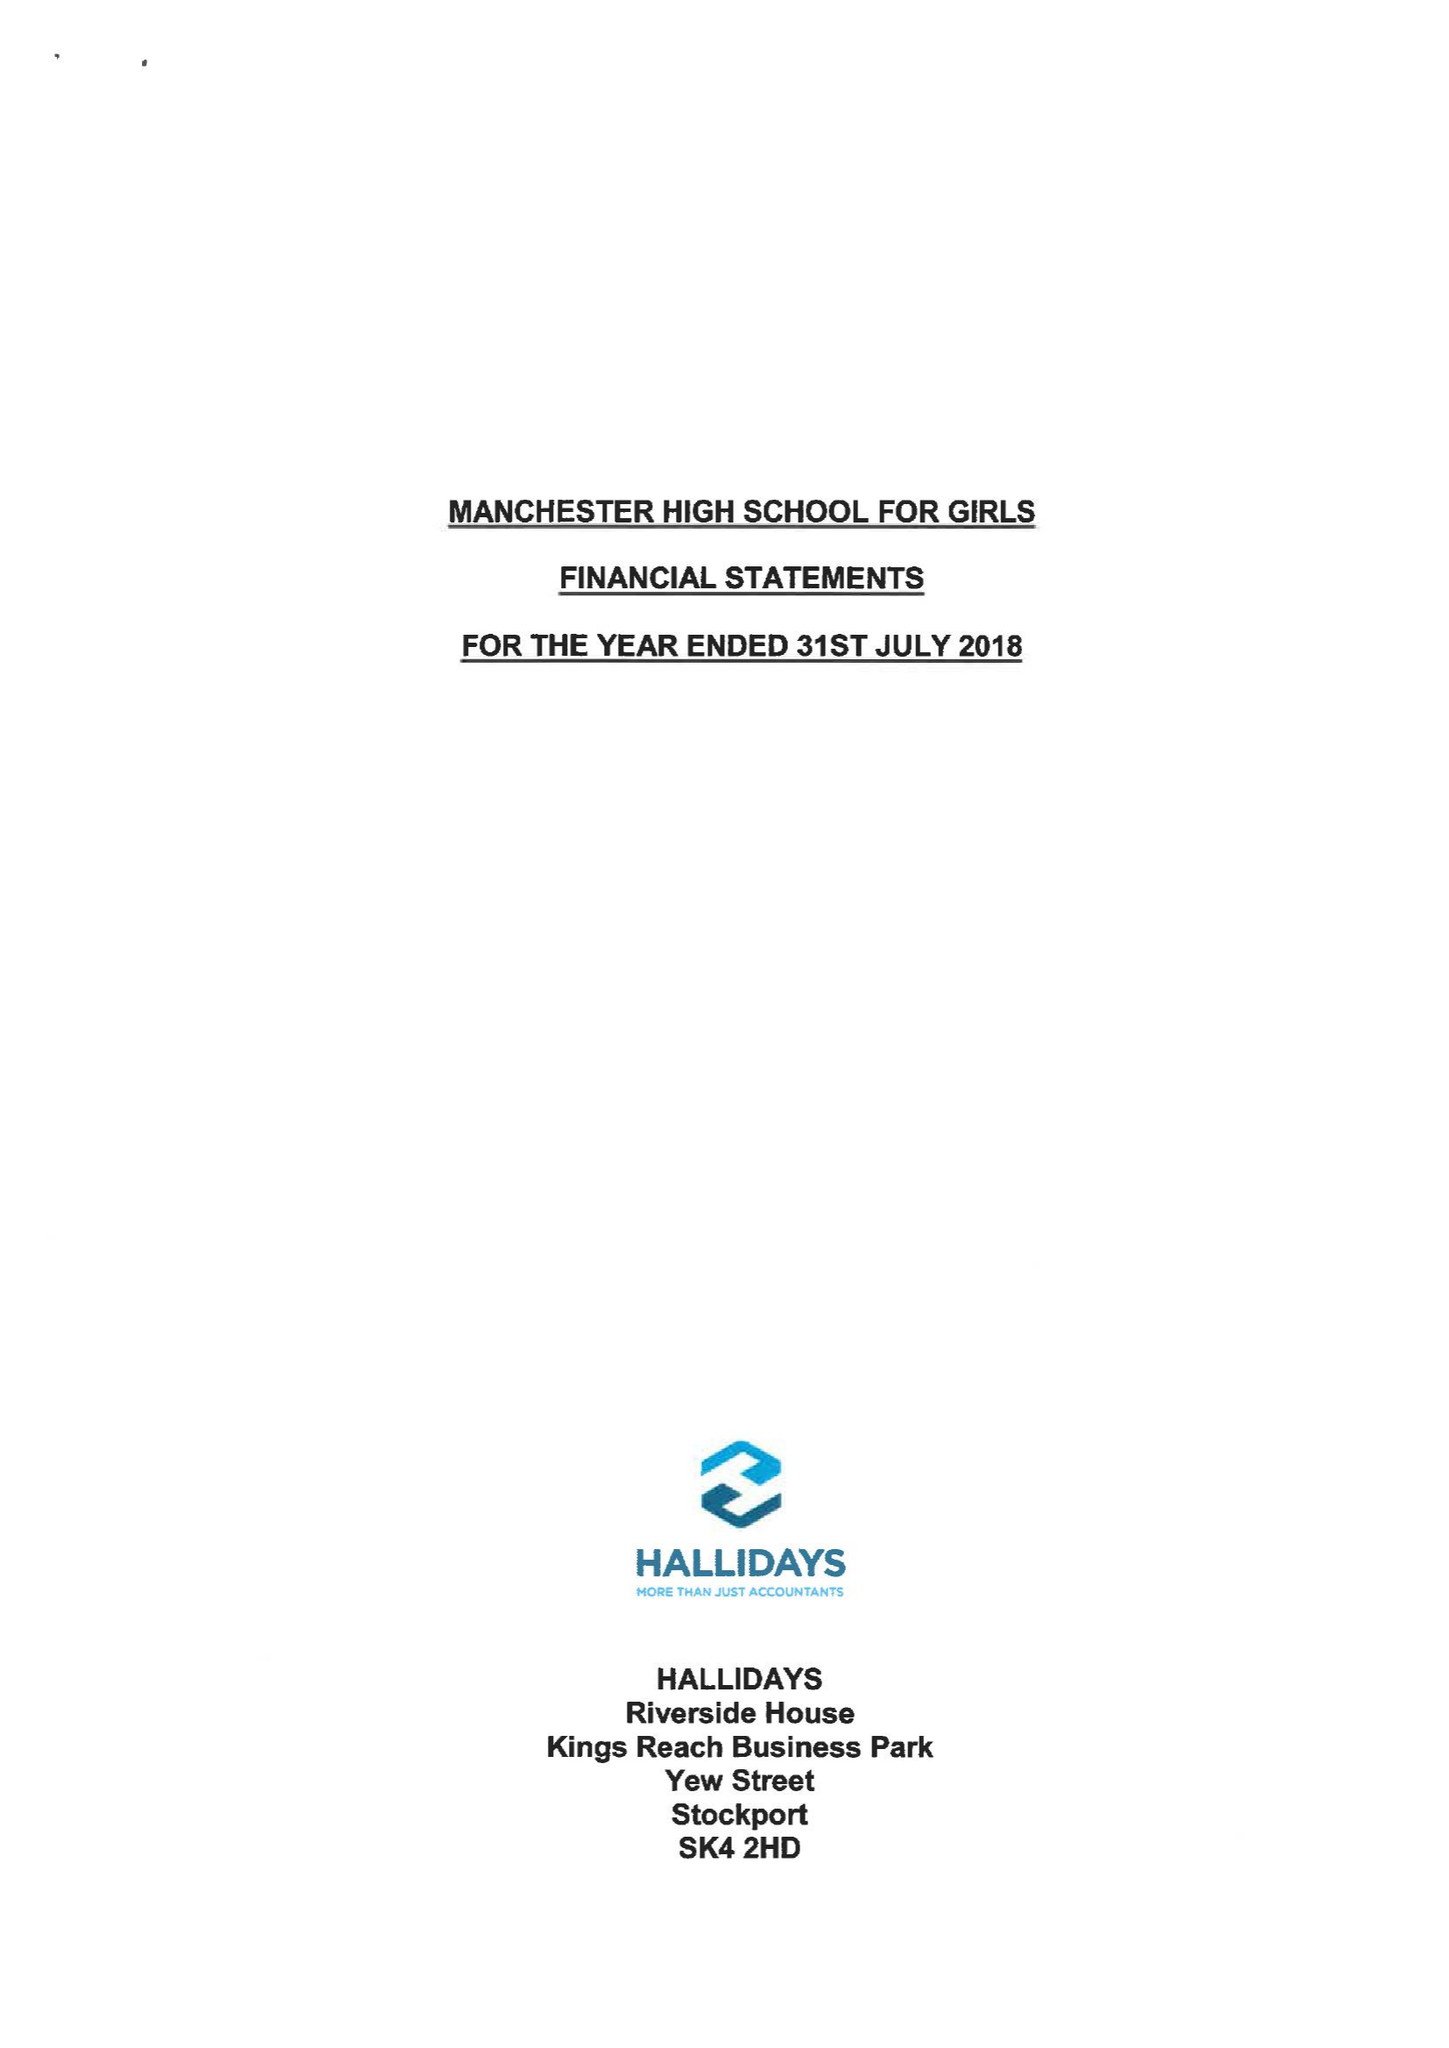What is the value for the charity_number?
Answer the question using a single word or phrase. 1164323 